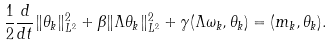Convert formula to latex. <formula><loc_0><loc_0><loc_500><loc_500>\frac { 1 } { 2 } \frac { d } { d t } \| \theta _ { k } \| _ { L ^ { 2 } } ^ { 2 } + \beta \| \Lambda \theta _ { k } \| _ { L ^ { 2 } } ^ { 2 } + \gamma ( \Lambda \omega _ { k } , \theta _ { k } ) = ( m _ { k } , \theta _ { k } ) .</formula> 